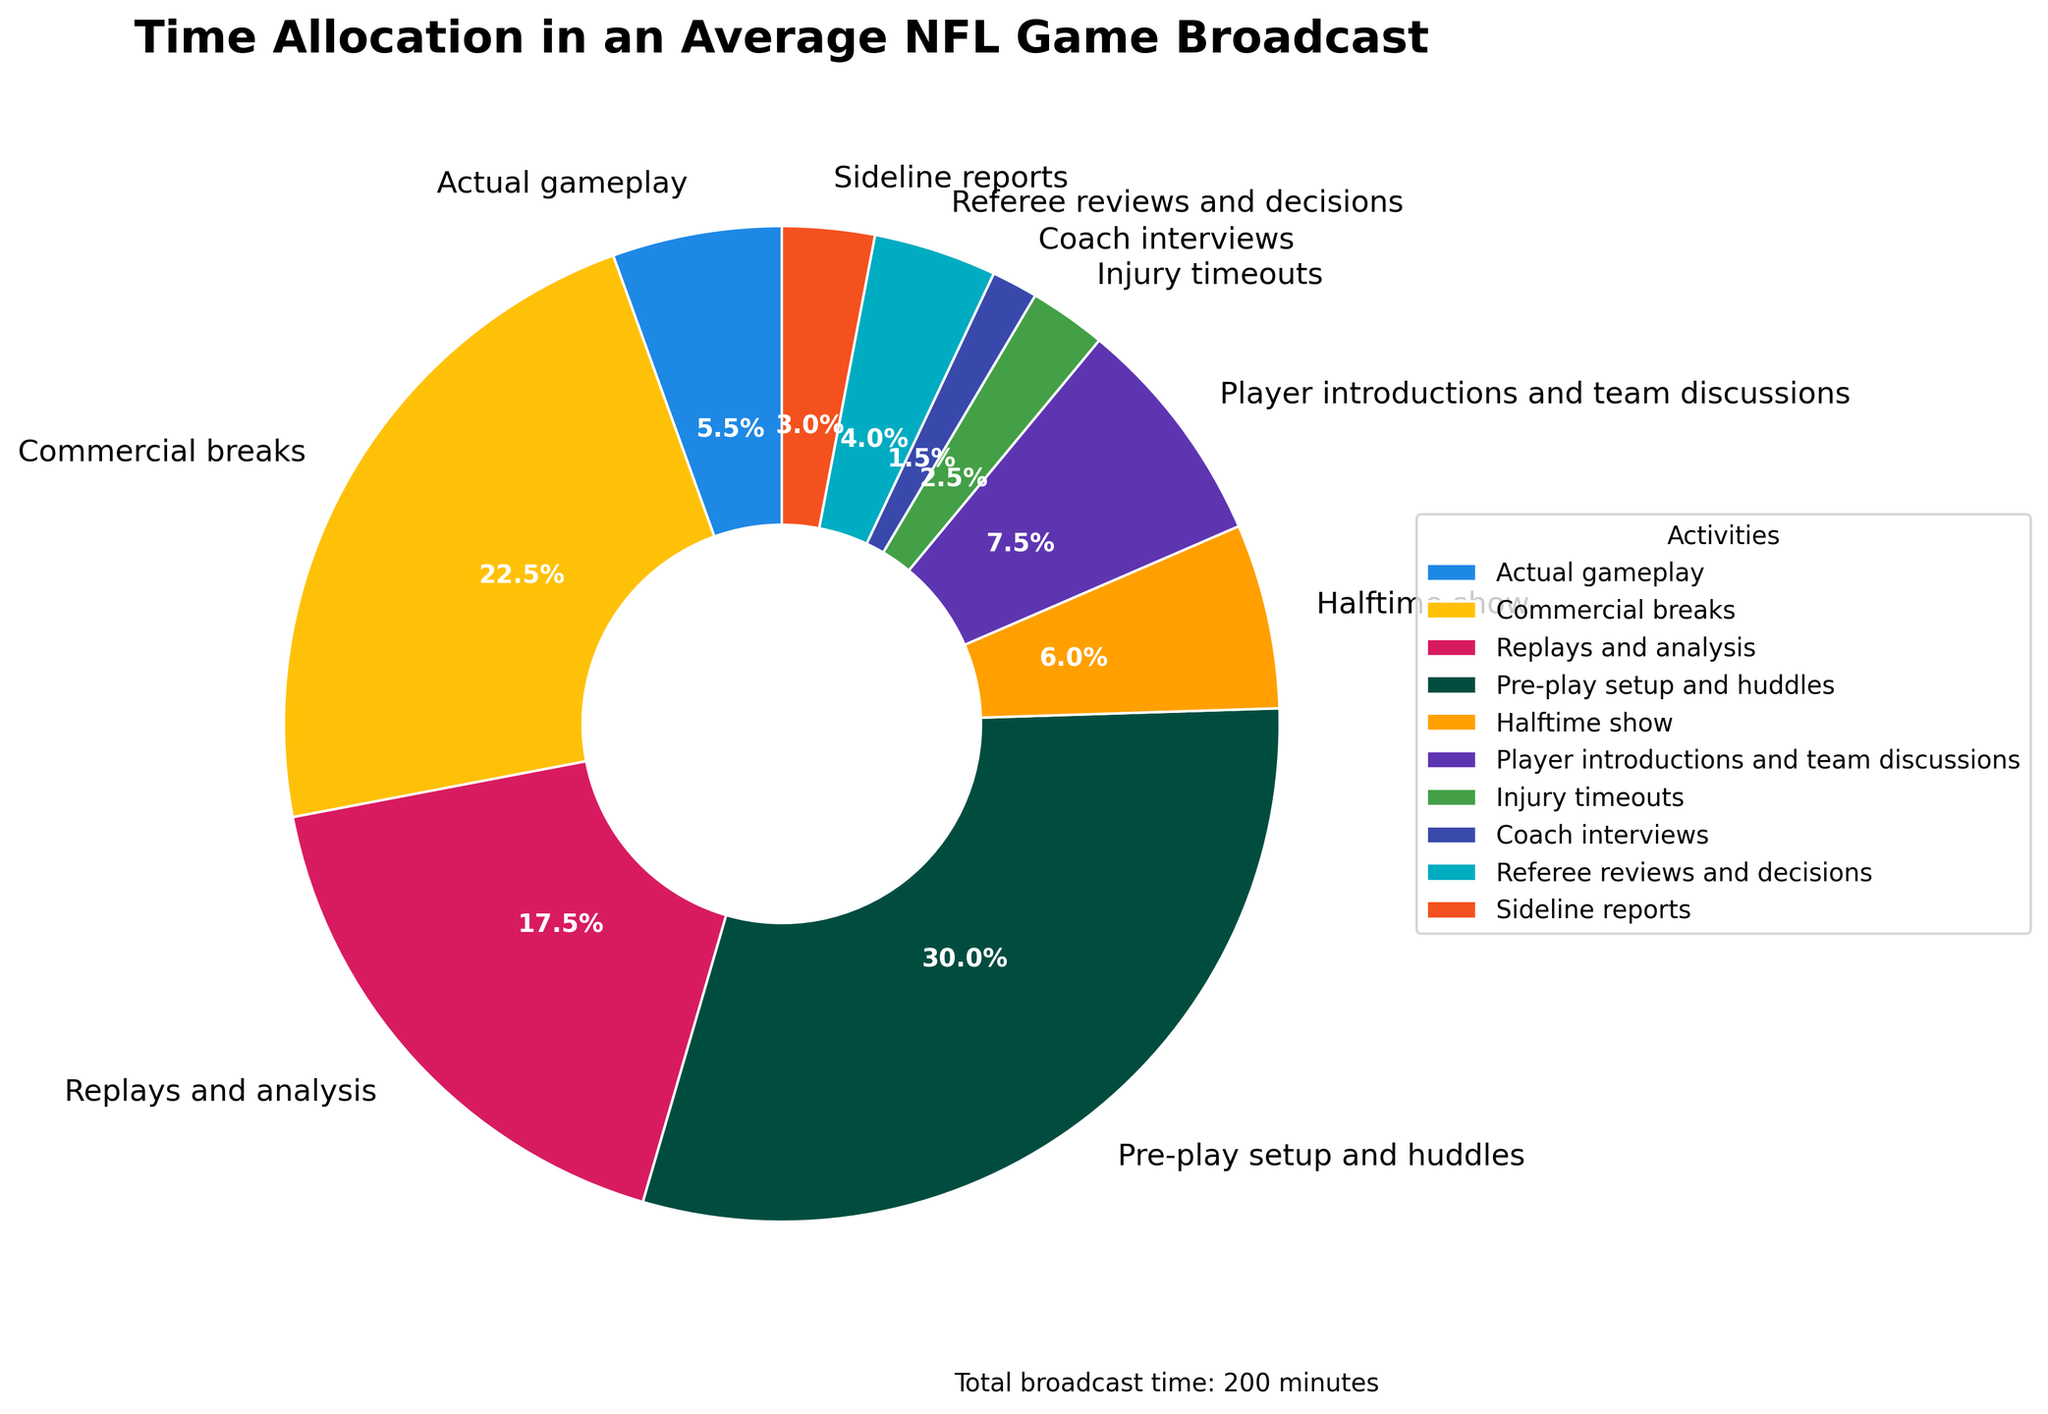What's the percentage for the broadcast time spent on replays and analysis? Locate the segment for "Replays and analysis" in the pie chart. The percentage is labeled directly on that segment.
Answer: 17.5% Which activity occupies the most broadcast time? Identify the largest segment in the pie chart. "Pre-play setup and huddles" is visually the largest.
Answer: Pre-play setup and huddles What is the combined percentage of time spent on commercials and actual gameplay? Find the percentages for "Commercial breaks" and "Actual gameplay," then add them: 22.5% + 5.5% = 28%.
Answer: 28% How does the time spent on the halftime show compare to that spent on injury timeouts? Compare the two activities "Halftime show" and "Injury timeouts" visually and through the percentages. "Halftime show" is slightly more than double "Injury timeouts." The segments show 6% and 2.5% respectively.
Answer: Halftime show is more, 6% vs 2.5% What is the total time allocated to player introductions, team discussions, and coach interviews? Add the minutes for "Player introductions and team discussions" (15 minutes) and "Coach interviews" (3 minutes): 15 + 3 = 18 minutes.
Answer: 18 minutes If replays and analysis were to be reduced by half, what would be the new percentage for that activity? Current percentage is 17.5%. Halving the minutes (so 35/2 = 17.5 minutes), then calculate: 17.5/200 = 8.75%.
Answer: 8.75% Which activity takes up less than 5% of the broadcast time? Identify segments with less than 5% labels. "Coach interviews" and "Injury timeouts" fit this criterion with 1.5% and 2.5%, respectively.
Answer: Coach interviews, Injury timeouts Why does the segment for "Commercial breaks" appear so large? The segment for "Commercial breaks" is larger because it accounts for a significant portion (22.5%) of the total broadcast time.
Answer: It accounts for 22.5% How much more time is spent on sideline reports compared to coach interviews? Locate the labels for "Sideline reports" and "Coach interviews." Calculate the difference in minutes: 6 - 3 = 3 minutes.
Answer: 3 minutes What percentage of the broadcast time is related to officiating and related activities (Referee reviews and decisions, and injury timeouts)? Combine the percentages for "Referee reviews and decisions" (4%) and "Injury timeouts" (2.5%): 4% + 2.5% = 6.5%.
Answer: 6.5% 